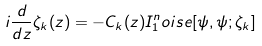<formula> <loc_0><loc_0><loc_500><loc_500>i \frac { d } { d z } \zeta _ { k } ( z ) = - C _ { k } ( z ) I _ { 1 } ^ { n } o i s e [ \psi , \psi ; \zeta _ { k } ] \,</formula> 